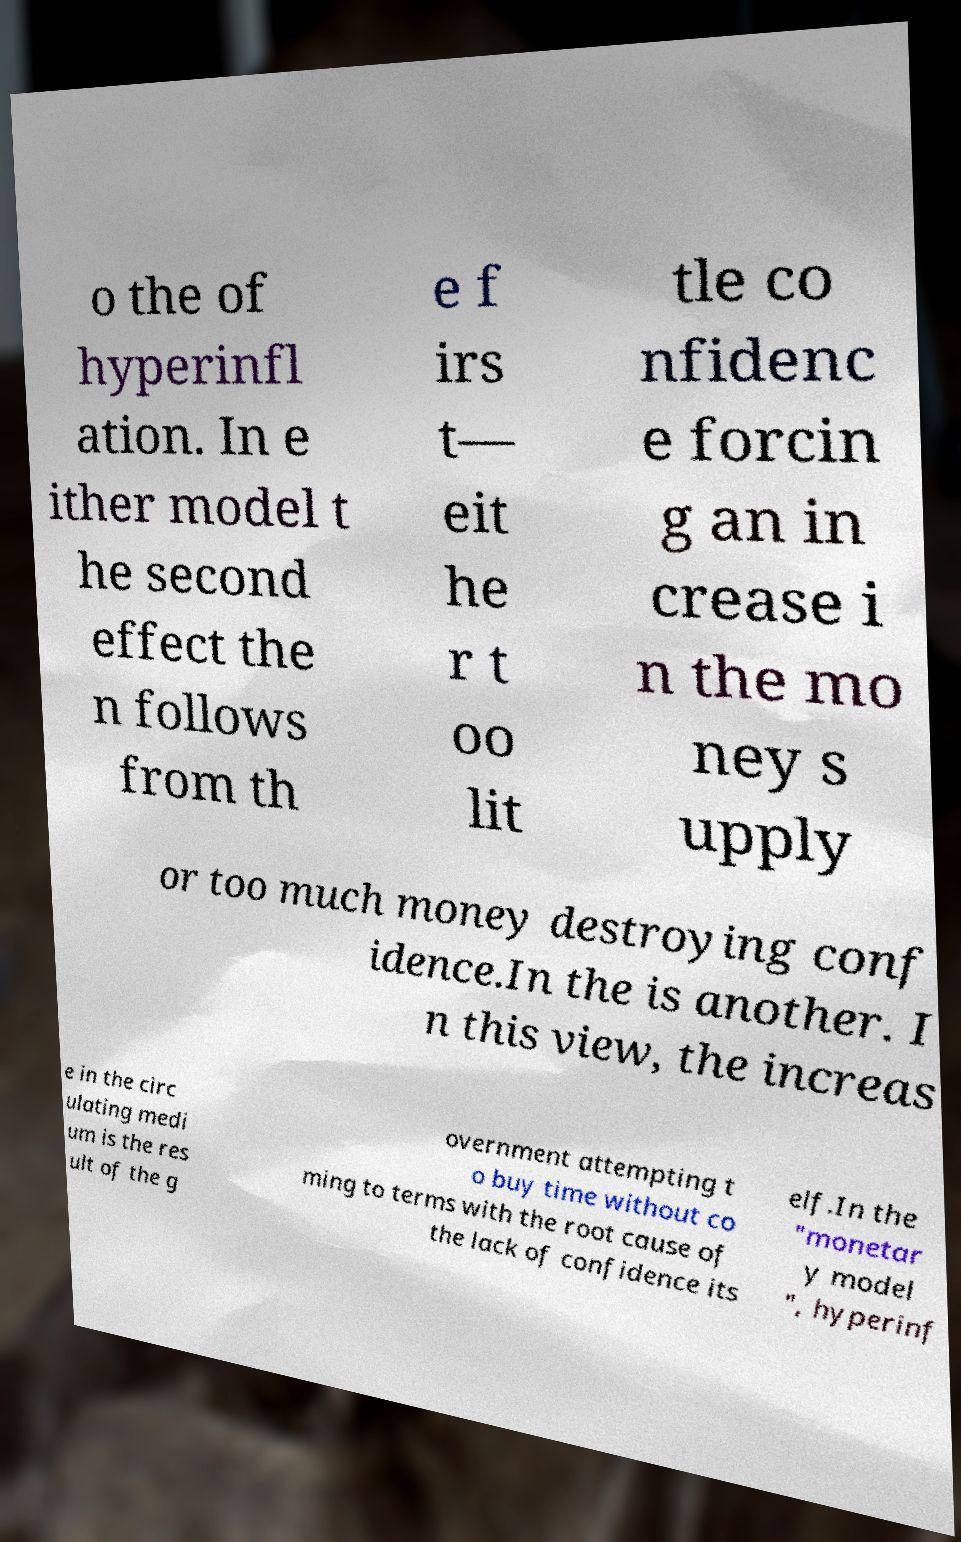Could you assist in decoding the text presented in this image and type it out clearly? o the of hyperinfl ation. In e ither model t he second effect the n follows from th e f irs t— eit he r t oo lit tle co nfidenc e forcin g an in crease i n the mo ney s upply or too much money destroying conf idence.In the is another. I n this view, the increas e in the circ ulating medi um is the res ult of the g overnment attempting t o buy time without co ming to terms with the root cause of the lack of confidence its elf.In the "monetar y model ", hyperinf 